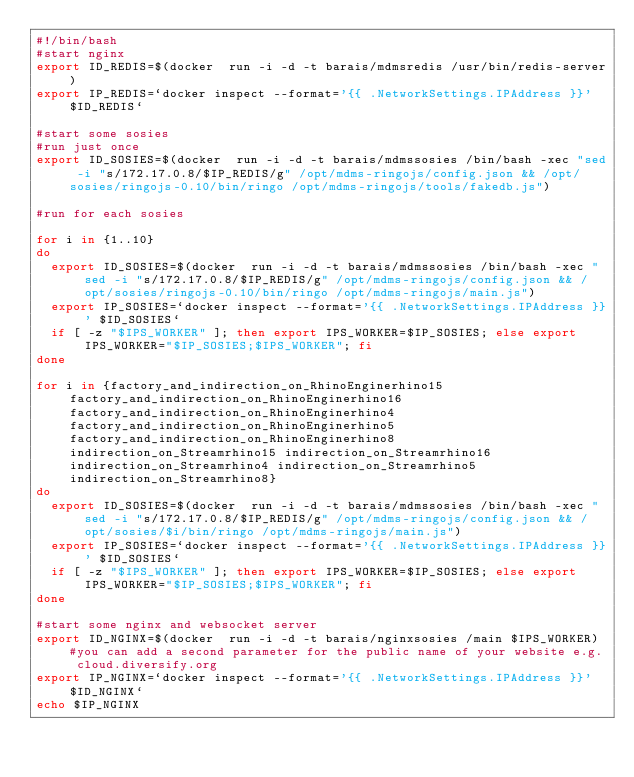<code> <loc_0><loc_0><loc_500><loc_500><_Bash_>#!/bin/bash
#start nginx
export ID_REDIS=$(docker  run -i -d -t barais/mdmsredis /usr/bin/redis-server)
export IP_REDIS=`docker inspect --format='{{ .NetworkSettings.IPAddress }}' $ID_REDIS`

#start some sosies
#run just once
export ID_SOSIES=$(docker  run -i -d -t barais/mdmssosies /bin/bash -xec "sed -i "s/172.17.0.8/$IP_REDIS/g" /opt/mdms-ringojs/config.json && /opt/sosies/ringojs-0.10/bin/ringo /opt/mdms-ringojs/tools/fakedb.js")

#run for each sosies

for i in {1..10}
do
	export ID_SOSIES=$(docker  run -i -d -t barais/mdmssosies /bin/bash -xec "sed -i "s/172.17.0.8/$IP_REDIS/g" /opt/mdms-ringojs/config.json && /opt/sosies/ringojs-0.10/bin/ringo /opt/mdms-ringojs/main.js")
	export IP_SOSIES=`docker inspect --format='{{ .NetworkSettings.IPAddress }}' $ID_SOSIES`
	if [ -z "$IPS_WORKER" ]; then export IPS_WORKER=$IP_SOSIES; else export IPS_WORKER="$IP_SOSIES;$IPS_WORKER"; fi  
done

for i in {factory_and_indirection_on_RhinoEnginerhino15 factory_and_indirection_on_RhinoEnginerhino16 factory_and_indirection_on_RhinoEnginerhino4 factory_and_indirection_on_RhinoEnginerhino5 factory_and_indirection_on_RhinoEnginerhino8 indirection_on_Streamrhino15 indirection_on_Streamrhino16 indirection_on_Streamrhino4 indirection_on_Streamrhino5 indirection_on_Streamrhino8}
do
	export ID_SOSIES=$(docker  run -i -d -t barais/mdmssosies /bin/bash -xec "sed -i "s/172.17.0.8/$IP_REDIS/g" /opt/mdms-ringojs/config.json && /opt/sosies/$i/bin/ringo /opt/mdms-ringojs/main.js")
	export IP_SOSIES=`docker inspect --format='{{ .NetworkSettings.IPAddress }}' $ID_SOSIES`
	if [ -z "$IPS_WORKER" ]; then export IPS_WORKER=$IP_SOSIES; else export IPS_WORKER="$IP_SOSIES;$IPS_WORKER"; fi  
done

#start some nginx and websocket server
export ID_NGINX=$(docker  run -i -d -t barais/nginxsosies /main $IPS_WORKER) #you can add a second parameter for the public name of your website e.g. cloud.diversify.org
export IP_NGINX=`docker inspect --format='{{ .NetworkSettings.IPAddress }}' $ID_NGINX`
echo $IP_NGINX



</code> 